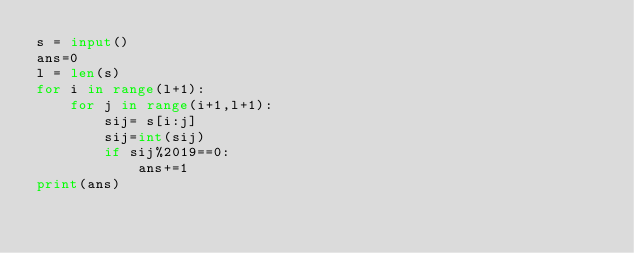<code> <loc_0><loc_0><loc_500><loc_500><_Python_>s = input()
ans=0
l = len(s)
for i in range(l+1):
    for j in range(i+1,l+1):
        sij= s[i:j]
        sij=int(sij)
        if sij%2019==0:
            ans+=1
print(ans)</code> 